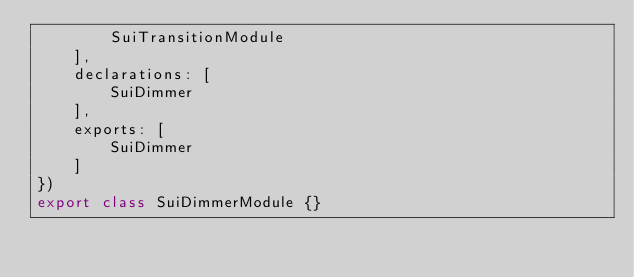<code> <loc_0><loc_0><loc_500><loc_500><_TypeScript_>        SuiTransitionModule
    ],
    declarations: [
        SuiDimmer
    ],
    exports: [
        SuiDimmer
    ]
})
export class SuiDimmerModule {}
</code> 